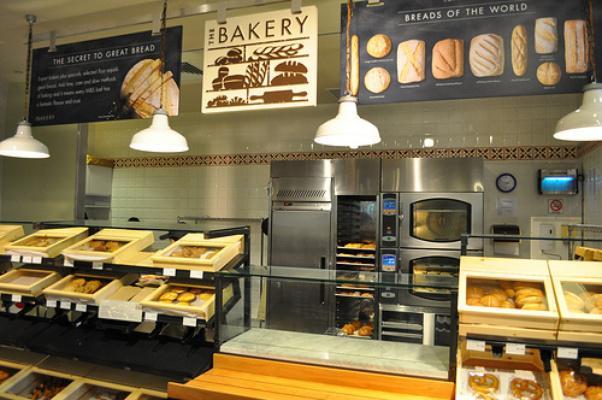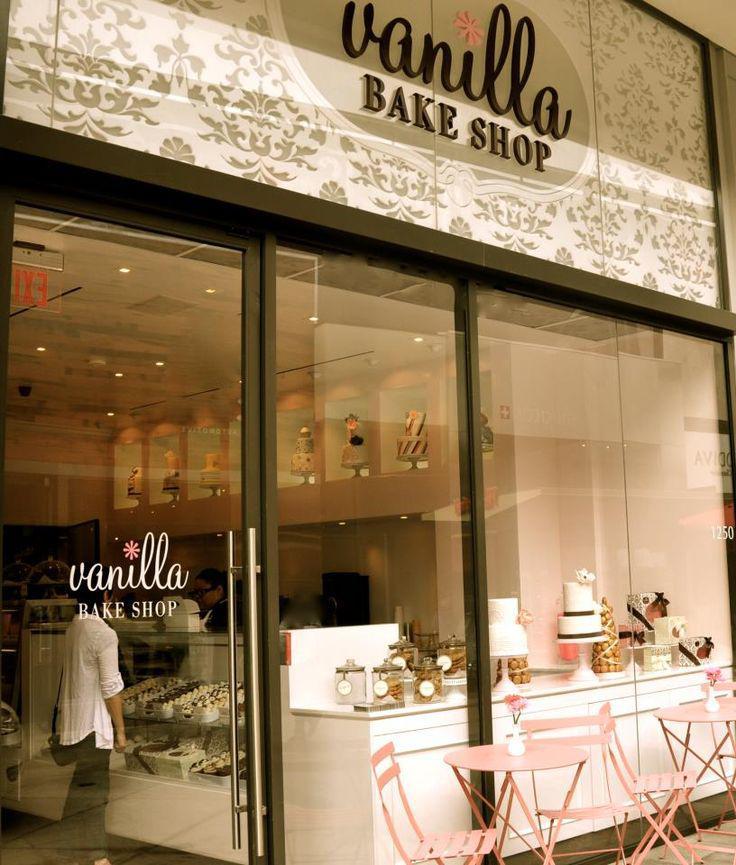The first image is the image on the left, the second image is the image on the right. Considering the images on both sides, is "There are exactly five lights hanging above the counter in the image on the right." valid? Answer yes or no. No. 